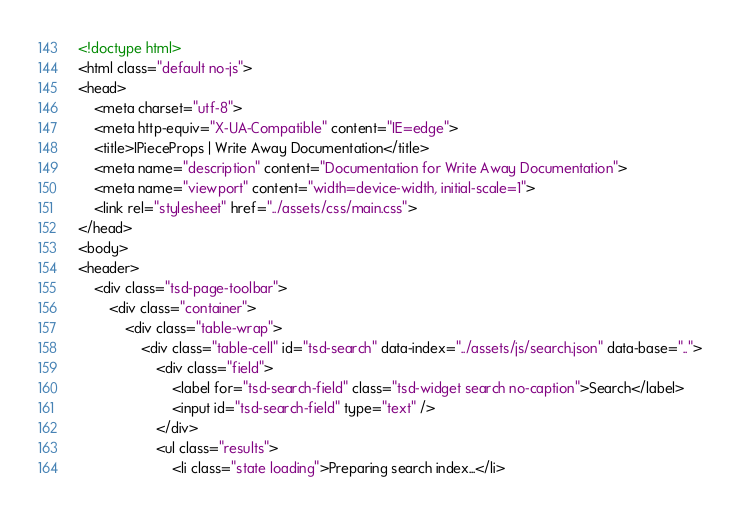<code> <loc_0><loc_0><loc_500><loc_500><_HTML_><!doctype html>
<html class="default no-js">
<head>
	<meta charset="utf-8">
	<meta http-equiv="X-UA-Compatible" content="IE=edge">
	<title>IPieceProps | Write Away Documentation</title>
	<meta name="description" content="Documentation for Write Away Documentation">
	<meta name="viewport" content="width=device-width, initial-scale=1">
	<link rel="stylesheet" href="../assets/css/main.css">
</head>
<body>
<header>
	<div class="tsd-page-toolbar">
		<div class="container">
			<div class="table-wrap">
				<div class="table-cell" id="tsd-search" data-index="../assets/js/search.json" data-base="..">
					<div class="field">
						<label for="tsd-search-field" class="tsd-widget search no-caption">Search</label>
						<input id="tsd-search-field" type="text" />
					</div>
					<ul class="results">
						<li class="state loading">Preparing search index...</li></code> 